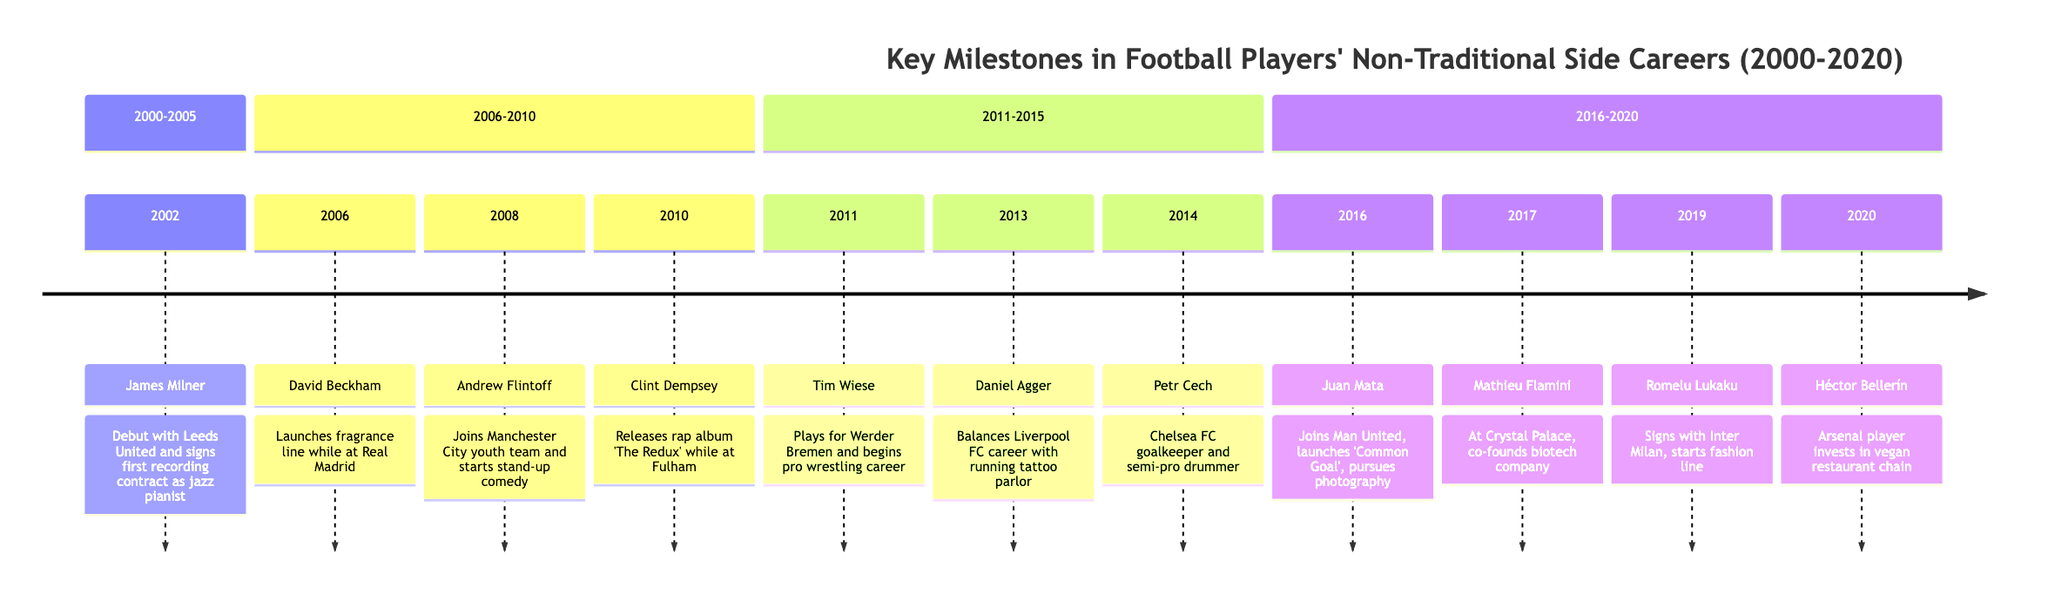What event happened in 2002? The event listed for the year 2002 in the timeline is "James Milner - Debut with Leeds United and signing his first recording contract as a jazz pianist."
Answer: James Milner - Debut with Leeds United and signing his first recording contract as a jazz pianist How many key milestones are recorded between 2006 and 2010? In the timeline section for 2006-2010, there are a total of three milestones: David Beckham in 2006, Andrew Flintoff in 2008, and Clint Dempsey in 2010.
Answer: 3 Which player released a rap album while playing for Fulham? The timeline specifies that "Clint Dempsey - Releases his rap album ‘The Redux’ while playing for Fulham."
Answer: Clint Dempsey What unique career did Tim Wiese pursue alongside football? The timeline notes that "Tim Wiese - Plays in goal for Werder Bremen and begins a professional wrestling career," indicating his dual career.
Answer: Professional wrestling Who launched a fragrance line while at Real Madrid? According to the timeline, "David Beckham - Launches his own fragrance line while playing for Real Madrid."
Answer: David Beckham Which player balanced their football career with running a tattoo parlor? The timeline specifies that "Daniel Agger - Balances playing for Liverpool FC and running a tattoo parlor."
Answer: Daniel Agger What is the common theme among the events listed in the timeline? Each listed event shows football players engaging in non-traditional side careers or hobbies, showcasing their diverse interests outside of football.
Answer: Non-traditional side careers Which two players are associated with the year 2016? The events for 2016 are tied to Juan Mata and Mathieu Flamini. Juan Mata joined Manchester United and launched the 'Common Goal' initiative, while Mathieu Flamini co-founded a biotech company.
Answer: Juan Mata, Mathieu Flamini What side job did Héctor Bellerín pursue while playing for Arsenal in 2020? The timeline states that "Héctor Bellerín - Invests in a vegan restaurant chain and continues to play for Arsenal," describing his side job.
Answer: Vegan restaurant chain 